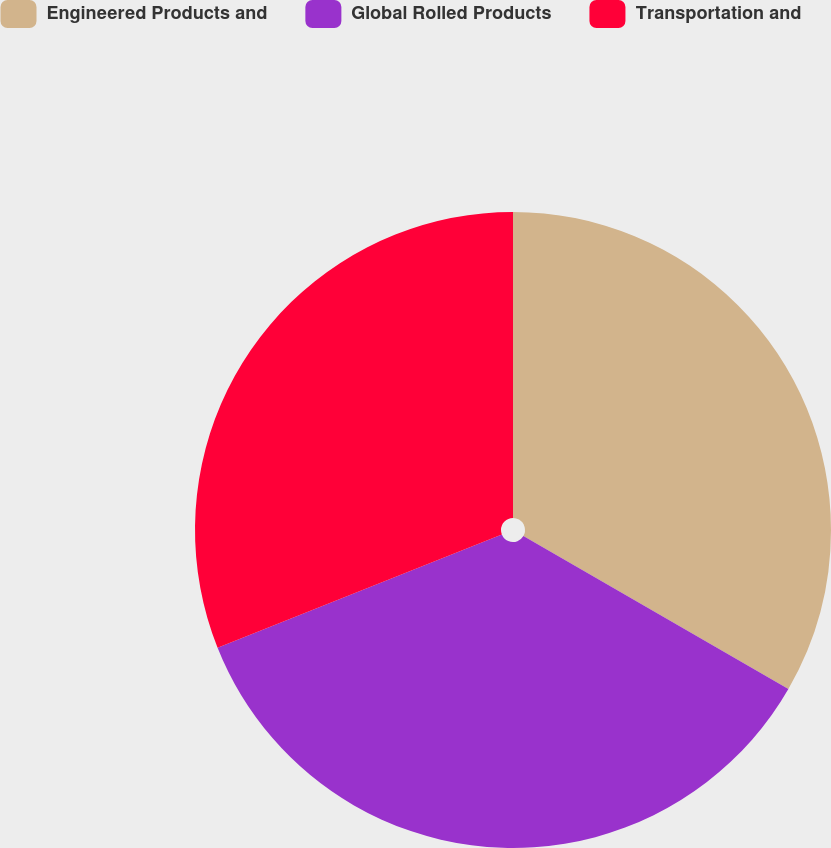<chart> <loc_0><loc_0><loc_500><loc_500><pie_chart><fcel>Engineered Products and<fcel>Global Rolled Products<fcel>Transportation and<nl><fcel>33.33%<fcel>35.63%<fcel>31.03%<nl></chart> 